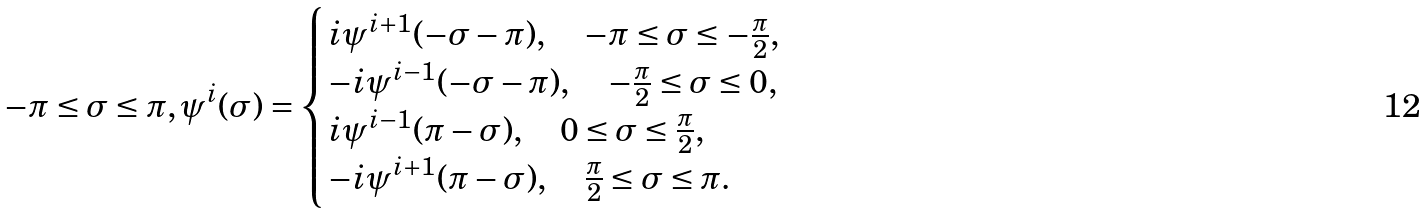<formula> <loc_0><loc_0><loc_500><loc_500>- \pi \leq \sigma \leq \pi , \psi ^ { i } ( \sigma ) = \begin{cases} i \psi ^ { i + 1 } ( - \sigma - \pi ) , \quad - \pi \leq \sigma \leq - \frac { \pi } { 2 } , \\ - i \psi ^ { i - 1 } ( - \sigma - \pi ) , \quad - \frac { \pi } { 2 } \leq \sigma \leq 0 , \\ i \psi ^ { i - 1 } ( \pi - \sigma ) , \quad 0 \leq \sigma \leq \frac { \pi } { 2 } , \\ - i \psi ^ { i + 1 } ( \pi - \sigma ) , \quad \frac { \pi } { 2 } \leq \sigma \leq \pi . \end{cases}</formula> 